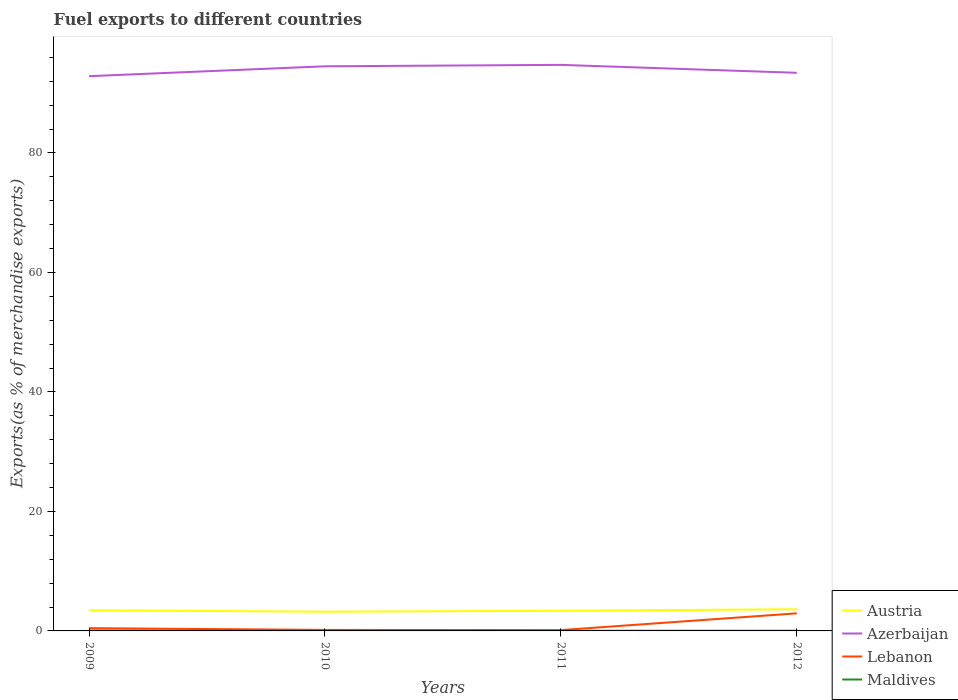How many different coloured lines are there?
Give a very brief answer. 4. Across all years, what is the maximum percentage of exports to different countries in Maldives?
Provide a succinct answer. 0.02. What is the total percentage of exports to different countries in Austria in the graph?
Provide a succinct answer. 0.09. What is the difference between the highest and the second highest percentage of exports to different countries in Maldives?
Offer a very short reply. 0.05. Is the percentage of exports to different countries in Lebanon strictly greater than the percentage of exports to different countries in Maldives over the years?
Give a very brief answer. No. How many lines are there?
Make the answer very short. 4. How many years are there in the graph?
Offer a terse response. 4. What is the difference between two consecutive major ticks on the Y-axis?
Your answer should be very brief. 20. Are the values on the major ticks of Y-axis written in scientific E-notation?
Your answer should be very brief. No. Does the graph contain any zero values?
Offer a very short reply. No. Where does the legend appear in the graph?
Offer a very short reply. Bottom right. How many legend labels are there?
Your answer should be compact. 4. How are the legend labels stacked?
Your answer should be very brief. Vertical. What is the title of the graph?
Give a very brief answer. Fuel exports to different countries. Does "Brunei Darussalam" appear as one of the legend labels in the graph?
Your answer should be very brief. No. What is the label or title of the Y-axis?
Make the answer very short. Exports(as % of merchandise exports). What is the Exports(as % of merchandise exports) of Austria in 2009?
Offer a terse response. 3.46. What is the Exports(as % of merchandise exports) in Azerbaijan in 2009?
Give a very brief answer. 92.86. What is the Exports(as % of merchandise exports) of Lebanon in 2009?
Make the answer very short. 0.46. What is the Exports(as % of merchandise exports) of Maldives in 2009?
Provide a short and direct response. 0.07. What is the Exports(as % of merchandise exports) in Austria in 2010?
Your answer should be compact. 3.22. What is the Exports(as % of merchandise exports) in Azerbaijan in 2010?
Your response must be concise. 94.51. What is the Exports(as % of merchandise exports) in Lebanon in 2010?
Offer a very short reply. 0.17. What is the Exports(as % of merchandise exports) of Maldives in 2010?
Provide a short and direct response. 0.02. What is the Exports(as % of merchandise exports) in Austria in 2011?
Give a very brief answer. 3.37. What is the Exports(as % of merchandise exports) in Azerbaijan in 2011?
Your response must be concise. 94.75. What is the Exports(as % of merchandise exports) in Lebanon in 2011?
Ensure brevity in your answer.  0.14. What is the Exports(as % of merchandise exports) of Maldives in 2011?
Provide a short and direct response. 0.03. What is the Exports(as % of merchandise exports) in Austria in 2012?
Provide a succinct answer. 3.62. What is the Exports(as % of merchandise exports) of Azerbaijan in 2012?
Provide a succinct answer. 93.42. What is the Exports(as % of merchandise exports) in Lebanon in 2012?
Offer a terse response. 2.94. What is the Exports(as % of merchandise exports) in Maldives in 2012?
Make the answer very short. 0.03. Across all years, what is the maximum Exports(as % of merchandise exports) of Austria?
Your answer should be compact. 3.62. Across all years, what is the maximum Exports(as % of merchandise exports) in Azerbaijan?
Keep it short and to the point. 94.75. Across all years, what is the maximum Exports(as % of merchandise exports) in Lebanon?
Your answer should be compact. 2.94. Across all years, what is the maximum Exports(as % of merchandise exports) in Maldives?
Offer a very short reply. 0.07. Across all years, what is the minimum Exports(as % of merchandise exports) in Austria?
Offer a very short reply. 3.22. Across all years, what is the minimum Exports(as % of merchandise exports) in Azerbaijan?
Provide a succinct answer. 92.86. Across all years, what is the minimum Exports(as % of merchandise exports) of Lebanon?
Give a very brief answer. 0.14. Across all years, what is the minimum Exports(as % of merchandise exports) in Maldives?
Your answer should be very brief. 0.02. What is the total Exports(as % of merchandise exports) in Austria in the graph?
Make the answer very short. 13.67. What is the total Exports(as % of merchandise exports) in Azerbaijan in the graph?
Your answer should be very brief. 375.53. What is the total Exports(as % of merchandise exports) of Lebanon in the graph?
Your answer should be very brief. 3.71. What is the total Exports(as % of merchandise exports) in Maldives in the graph?
Ensure brevity in your answer.  0.16. What is the difference between the Exports(as % of merchandise exports) in Austria in 2009 and that in 2010?
Make the answer very short. 0.24. What is the difference between the Exports(as % of merchandise exports) in Azerbaijan in 2009 and that in 2010?
Provide a short and direct response. -1.65. What is the difference between the Exports(as % of merchandise exports) of Lebanon in 2009 and that in 2010?
Keep it short and to the point. 0.29. What is the difference between the Exports(as % of merchandise exports) in Maldives in 2009 and that in 2010?
Ensure brevity in your answer.  0.05. What is the difference between the Exports(as % of merchandise exports) in Austria in 2009 and that in 2011?
Offer a terse response. 0.09. What is the difference between the Exports(as % of merchandise exports) in Azerbaijan in 2009 and that in 2011?
Your answer should be very brief. -1.89. What is the difference between the Exports(as % of merchandise exports) of Lebanon in 2009 and that in 2011?
Ensure brevity in your answer.  0.32. What is the difference between the Exports(as % of merchandise exports) of Maldives in 2009 and that in 2011?
Make the answer very short. 0.04. What is the difference between the Exports(as % of merchandise exports) in Austria in 2009 and that in 2012?
Ensure brevity in your answer.  -0.17. What is the difference between the Exports(as % of merchandise exports) of Azerbaijan in 2009 and that in 2012?
Offer a terse response. -0.56. What is the difference between the Exports(as % of merchandise exports) in Lebanon in 2009 and that in 2012?
Offer a very short reply. -2.48. What is the difference between the Exports(as % of merchandise exports) in Maldives in 2009 and that in 2012?
Provide a succinct answer. 0.04. What is the difference between the Exports(as % of merchandise exports) in Austria in 2010 and that in 2011?
Provide a succinct answer. -0.15. What is the difference between the Exports(as % of merchandise exports) in Azerbaijan in 2010 and that in 2011?
Provide a succinct answer. -0.24. What is the difference between the Exports(as % of merchandise exports) of Lebanon in 2010 and that in 2011?
Provide a short and direct response. 0.03. What is the difference between the Exports(as % of merchandise exports) of Maldives in 2010 and that in 2011?
Provide a succinct answer. -0.01. What is the difference between the Exports(as % of merchandise exports) of Austria in 2010 and that in 2012?
Offer a terse response. -0.41. What is the difference between the Exports(as % of merchandise exports) in Azerbaijan in 2010 and that in 2012?
Make the answer very short. 1.09. What is the difference between the Exports(as % of merchandise exports) in Lebanon in 2010 and that in 2012?
Offer a very short reply. -2.77. What is the difference between the Exports(as % of merchandise exports) of Maldives in 2010 and that in 2012?
Give a very brief answer. -0.01. What is the difference between the Exports(as % of merchandise exports) in Austria in 2011 and that in 2012?
Give a very brief answer. -0.25. What is the difference between the Exports(as % of merchandise exports) in Azerbaijan in 2011 and that in 2012?
Your answer should be compact. 1.33. What is the difference between the Exports(as % of merchandise exports) of Lebanon in 2011 and that in 2012?
Provide a succinct answer. -2.8. What is the difference between the Exports(as % of merchandise exports) in Maldives in 2011 and that in 2012?
Ensure brevity in your answer.  -0.01. What is the difference between the Exports(as % of merchandise exports) in Austria in 2009 and the Exports(as % of merchandise exports) in Azerbaijan in 2010?
Your response must be concise. -91.05. What is the difference between the Exports(as % of merchandise exports) in Austria in 2009 and the Exports(as % of merchandise exports) in Lebanon in 2010?
Provide a short and direct response. 3.29. What is the difference between the Exports(as % of merchandise exports) of Austria in 2009 and the Exports(as % of merchandise exports) of Maldives in 2010?
Provide a succinct answer. 3.43. What is the difference between the Exports(as % of merchandise exports) of Azerbaijan in 2009 and the Exports(as % of merchandise exports) of Lebanon in 2010?
Your answer should be compact. 92.69. What is the difference between the Exports(as % of merchandise exports) of Azerbaijan in 2009 and the Exports(as % of merchandise exports) of Maldives in 2010?
Your response must be concise. 92.83. What is the difference between the Exports(as % of merchandise exports) in Lebanon in 2009 and the Exports(as % of merchandise exports) in Maldives in 2010?
Make the answer very short. 0.44. What is the difference between the Exports(as % of merchandise exports) of Austria in 2009 and the Exports(as % of merchandise exports) of Azerbaijan in 2011?
Offer a terse response. -91.29. What is the difference between the Exports(as % of merchandise exports) in Austria in 2009 and the Exports(as % of merchandise exports) in Lebanon in 2011?
Offer a terse response. 3.32. What is the difference between the Exports(as % of merchandise exports) of Austria in 2009 and the Exports(as % of merchandise exports) of Maldives in 2011?
Your response must be concise. 3.43. What is the difference between the Exports(as % of merchandise exports) in Azerbaijan in 2009 and the Exports(as % of merchandise exports) in Lebanon in 2011?
Offer a terse response. 92.72. What is the difference between the Exports(as % of merchandise exports) in Azerbaijan in 2009 and the Exports(as % of merchandise exports) in Maldives in 2011?
Make the answer very short. 92.83. What is the difference between the Exports(as % of merchandise exports) in Lebanon in 2009 and the Exports(as % of merchandise exports) in Maldives in 2011?
Make the answer very short. 0.43. What is the difference between the Exports(as % of merchandise exports) in Austria in 2009 and the Exports(as % of merchandise exports) in Azerbaijan in 2012?
Your response must be concise. -89.96. What is the difference between the Exports(as % of merchandise exports) of Austria in 2009 and the Exports(as % of merchandise exports) of Lebanon in 2012?
Offer a very short reply. 0.52. What is the difference between the Exports(as % of merchandise exports) in Austria in 2009 and the Exports(as % of merchandise exports) in Maldives in 2012?
Provide a short and direct response. 3.42. What is the difference between the Exports(as % of merchandise exports) of Azerbaijan in 2009 and the Exports(as % of merchandise exports) of Lebanon in 2012?
Keep it short and to the point. 89.92. What is the difference between the Exports(as % of merchandise exports) of Azerbaijan in 2009 and the Exports(as % of merchandise exports) of Maldives in 2012?
Make the answer very short. 92.82. What is the difference between the Exports(as % of merchandise exports) of Lebanon in 2009 and the Exports(as % of merchandise exports) of Maldives in 2012?
Make the answer very short. 0.43. What is the difference between the Exports(as % of merchandise exports) of Austria in 2010 and the Exports(as % of merchandise exports) of Azerbaijan in 2011?
Keep it short and to the point. -91.53. What is the difference between the Exports(as % of merchandise exports) of Austria in 2010 and the Exports(as % of merchandise exports) of Lebanon in 2011?
Give a very brief answer. 3.08. What is the difference between the Exports(as % of merchandise exports) of Austria in 2010 and the Exports(as % of merchandise exports) of Maldives in 2011?
Ensure brevity in your answer.  3.19. What is the difference between the Exports(as % of merchandise exports) of Azerbaijan in 2010 and the Exports(as % of merchandise exports) of Lebanon in 2011?
Offer a very short reply. 94.37. What is the difference between the Exports(as % of merchandise exports) in Azerbaijan in 2010 and the Exports(as % of merchandise exports) in Maldives in 2011?
Ensure brevity in your answer.  94.48. What is the difference between the Exports(as % of merchandise exports) of Lebanon in 2010 and the Exports(as % of merchandise exports) of Maldives in 2011?
Offer a terse response. 0.14. What is the difference between the Exports(as % of merchandise exports) of Austria in 2010 and the Exports(as % of merchandise exports) of Azerbaijan in 2012?
Your response must be concise. -90.2. What is the difference between the Exports(as % of merchandise exports) in Austria in 2010 and the Exports(as % of merchandise exports) in Lebanon in 2012?
Your response must be concise. 0.28. What is the difference between the Exports(as % of merchandise exports) of Austria in 2010 and the Exports(as % of merchandise exports) of Maldives in 2012?
Your answer should be very brief. 3.18. What is the difference between the Exports(as % of merchandise exports) in Azerbaijan in 2010 and the Exports(as % of merchandise exports) in Lebanon in 2012?
Your answer should be very brief. 91.57. What is the difference between the Exports(as % of merchandise exports) of Azerbaijan in 2010 and the Exports(as % of merchandise exports) of Maldives in 2012?
Offer a very short reply. 94.48. What is the difference between the Exports(as % of merchandise exports) of Lebanon in 2010 and the Exports(as % of merchandise exports) of Maldives in 2012?
Provide a short and direct response. 0.14. What is the difference between the Exports(as % of merchandise exports) in Austria in 2011 and the Exports(as % of merchandise exports) in Azerbaijan in 2012?
Ensure brevity in your answer.  -90.05. What is the difference between the Exports(as % of merchandise exports) in Austria in 2011 and the Exports(as % of merchandise exports) in Lebanon in 2012?
Your response must be concise. 0.43. What is the difference between the Exports(as % of merchandise exports) of Austria in 2011 and the Exports(as % of merchandise exports) of Maldives in 2012?
Provide a succinct answer. 3.34. What is the difference between the Exports(as % of merchandise exports) in Azerbaijan in 2011 and the Exports(as % of merchandise exports) in Lebanon in 2012?
Offer a terse response. 91.81. What is the difference between the Exports(as % of merchandise exports) in Azerbaijan in 2011 and the Exports(as % of merchandise exports) in Maldives in 2012?
Keep it short and to the point. 94.71. What is the difference between the Exports(as % of merchandise exports) of Lebanon in 2011 and the Exports(as % of merchandise exports) of Maldives in 2012?
Provide a short and direct response. 0.1. What is the average Exports(as % of merchandise exports) in Austria per year?
Keep it short and to the point. 3.42. What is the average Exports(as % of merchandise exports) in Azerbaijan per year?
Your response must be concise. 93.88. What is the average Exports(as % of merchandise exports) in Lebanon per year?
Keep it short and to the point. 0.93. What is the average Exports(as % of merchandise exports) of Maldives per year?
Keep it short and to the point. 0.04. In the year 2009, what is the difference between the Exports(as % of merchandise exports) of Austria and Exports(as % of merchandise exports) of Azerbaijan?
Offer a terse response. -89.4. In the year 2009, what is the difference between the Exports(as % of merchandise exports) in Austria and Exports(as % of merchandise exports) in Lebanon?
Provide a succinct answer. 2.99. In the year 2009, what is the difference between the Exports(as % of merchandise exports) in Austria and Exports(as % of merchandise exports) in Maldives?
Your answer should be very brief. 3.38. In the year 2009, what is the difference between the Exports(as % of merchandise exports) in Azerbaijan and Exports(as % of merchandise exports) in Lebanon?
Ensure brevity in your answer.  92.4. In the year 2009, what is the difference between the Exports(as % of merchandise exports) in Azerbaijan and Exports(as % of merchandise exports) in Maldives?
Your response must be concise. 92.78. In the year 2009, what is the difference between the Exports(as % of merchandise exports) of Lebanon and Exports(as % of merchandise exports) of Maldives?
Offer a terse response. 0.39. In the year 2010, what is the difference between the Exports(as % of merchandise exports) in Austria and Exports(as % of merchandise exports) in Azerbaijan?
Provide a short and direct response. -91.29. In the year 2010, what is the difference between the Exports(as % of merchandise exports) in Austria and Exports(as % of merchandise exports) in Lebanon?
Your response must be concise. 3.05. In the year 2010, what is the difference between the Exports(as % of merchandise exports) of Austria and Exports(as % of merchandise exports) of Maldives?
Keep it short and to the point. 3.2. In the year 2010, what is the difference between the Exports(as % of merchandise exports) in Azerbaijan and Exports(as % of merchandise exports) in Lebanon?
Offer a terse response. 94.34. In the year 2010, what is the difference between the Exports(as % of merchandise exports) of Azerbaijan and Exports(as % of merchandise exports) of Maldives?
Give a very brief answer. 94.49. In the year 2010, what is the difference between the Exports(as % of merchandise exports) of Lebanon and Exports(as % of merchandise exports) of Maldives?
Ensure brevity in your answer.  0.15. In the year 2011, what is the difference between the Exports(as % of merchandise exports) of Austria and Exports(as % of merchandise exports) of Azerbaijan?
Provide a succinct answer. -91.38. In the year 2011, what is the difference between the Exports(as % of merchandise exports) in Austria and Exports(as % of merchandise exports) in Lebanon?
Your answer should be compact. 3.23. In the year 2011, what is the difference between the Exports(as % of merchandise exports) of Austria and Exports(as % of merchandise exports) of Maldives?
Give a very brief answer. 3.34. In the year 2011, what is the difference between the Exports(as % of merchandise exports) in Azerbaijan and Exports(as % of merchandise exports) in Lebanon?
Keep it short and to the point. 94.61. In the year 2011, what is the difference between the Exports(as % of merchandise exports) in Azerbaijan and Exports(as % of merchandise exports) in Maldives?
Give a very brief answer. 94.72. In the year 2011, what is the difference between the Exports(as % of merchandise exports) in Lebanon and Exports(as % of merchandise exports) in Maldives?
Your answer should be very brief. 0.11. In the year 2012, what is the difference between the Exports(as % of merchandise exports) in Austria and Exports(as % of merchandise exports) in Azerbaijan?
Make the answer very short. -89.79. In the year 2012, what is the difference between the Exports(as % of merchandise exports) in Austria and Exports(as % of merchandise exports) in Lebanon?
Your answer should be very brief. 0.68. In the year 2012, what is the difference between the Exports(as % of merchandise exports) of Austria and Exports(as % of merchandise exports) of Maldives?
Offer a very short reply. 3.59. In the year 2012, what is the difference between the Exports(as % of merchandise exports) of Azerbaijan and Exports(as % of merchandise exports) of Lebanon?
Keep it short and to the point. 90.48. In the year 2012, what is the difference between the Exports(as % of merchandise exports) of Azerbaijan and Exports(as % of merchandise exports) of Maldives?
Keep it short and to the point. 93.39. In the year 2012, what is the difference between the Exports(as % of merchandise exports) in Lebanon and Exports(as % of merchandise exports) in Maldives?
Your response must be concise. 2.91. What is the ratio of the Exports(as % of merchandise exports) of Austria in 2009 to that in 2010?
Offer a very short reply. 1.07. What is the ratio of the Exports(as % of merchandise exports) of Azerbaijan in 2009 to that in 2010?
Your answer should be compact. 0.98. What is the ratio of the Exports(as % of merchandise exports) in Lebanon in 2009 to that in 2010?
Give a very brief answer. 2.71. What is the ratio of the Exports(as % of merchandise exports) in Maldives in 2009 to that in 2010?
Make the answer very short. 3.12. What is the ratio of the Exports(as % of merchandise exports) of Austria in 2009 to that in 2011?
Your response must be concise. 1.03. What is the ratio of the Exports(as % of merchandise exports) of Azerbaijan in 2009 to that in 2011?
Your answer should be compact. 0.98. What is the ratio of the Exports(as % of merchandise exports) in Lebanon in 2009 to that in 2011?
Make the answer very short. 3.34. What is the ratio of the Exports(as % of merchandise exports) of Maldives in 2009 to that in 2011?
Give a very brief answer. 2.48. What is the ratio of the Exports(as % of merchandise exports) of Austria in 2009 to that in 2012?
Provide a short and direct response. 0.95. What is the ratio of the Exports(as % of merchandise exports) in Azerbaijan in 2009 to that in 2012?
Give a very brief answer. 0.99. What is the ratio of the Exports(as % of merchandise exports) in Lebanon in 2009 to that in 2012?
Ensure brevity in your answer.  0.16. What is the ratio of the Exports(as % of merchandise exports) in Maldives in 2009 to that in 2012?
Provide a short and direct response. 2.11. What is the ratio of the Exports(as % of merchandise exports) in Austria in 2010 to that in 2011?
Keep it short and to the point. 0.95. What is the ratio of the Exports(as % of merchandise exports) of Azerbaijan in 2010 to that in 2011?
Keep it short and to the point. 1. What is the ratio of the Exports(as % of merchandise exports) in Lebanon in 2010 to that in 2011?
Your answer should be compact. 1.23. What is the ratio of the Exports(as % of merchandise exports) in Maldives in 2010 to that in 2011?
Provide a succinct answer. 0.8. What is the ratio of the Exports(as % of merchandise exports) of Austria in 2010 to that in 2012?
Your answer should be compact. 0.89. What is the ratio of the Exports(as % of merchandise exports) in Azerbaijan in 2010 to that in 2012?
Offer a very short reply. 1.01. What is the ratio of the Exports(as % of merchandise exports) of Lebanon in 2010 to that in 2012?
Your answer should be compact. 0.06. What is the ratio of the Exports(as % of merchandise exports) in Maldives in 2010 to that in 2012?
Ensure brevity in your answer.  0.68. What is the ratio of the Exports(as % of merchandise exports) of Austria in 2011 to that in 2012?
Provide a succinct answer. 0.93. What is the ratio of the Exports(as % of merchandise exports) of Azerbaijan in 2011 to that in 2012?
Your response must be concise. 1.01. What is the ratio of the Exports(as % of merchandise exports) of Lebanon in 2011 to that in 2012?
Your answer should be compact. 0.05. What is the ratio of the Exports(as % of merchandise exports) in Maldives in 2011 to that in 2012?
Provide a short and direct response. 0.85. What is the difference between the highest and the second highest Exports(as % of merchandise exports) of Austria?
Your answer should be very brief. 0.17. What is the difference between the highest and the second highest Exports(as % of merchandise exports) of Azerbaijan?
Offer a very short reply. 0.24. What is the difference between the highest and the second highest Exports(as % of merchandise exports) in Lebanon?
Provide a succinct answer. 2.48. What is the difference between the highest and the second highest Exports(as % of merchandise exports) in Maldives?
Your response must be concise. 0.04. What is the difference between the highest and the lowest Exports(as % of merchandise exports) in Austria?
Offer a terse response. 0.41. What is the difference between the highest and the lowest Exports(as % of merchandise exports) of Azerbaijan?
Keep it short and to the point. 1.89. What is the difference between the highest and the lowest Exports(as % of merchandise exports) of Lebanon?
Your response must be concise. 2.8. What is the difference between the highest and the lowest Exports(as % of merchandise exports) in Maldives?
Your answer should be very brief. 0.05. 